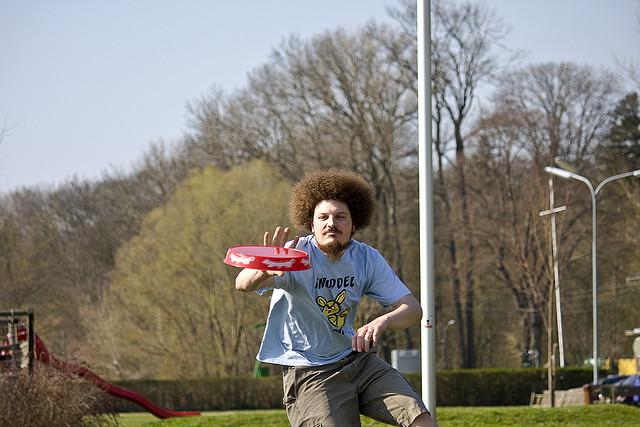What character is on the boys shirt?
Give a very brief answer. Pokemon. Is the Frisbee right side-up or upside-down?
Quick response, please. Right side up. What is the man holding in his hand?
Be succinct. Frisbee. What kind of hairstyle does the man have?
Write a very short answer. Afro. What color is the Frisbee?
Keep it brief. Red. 